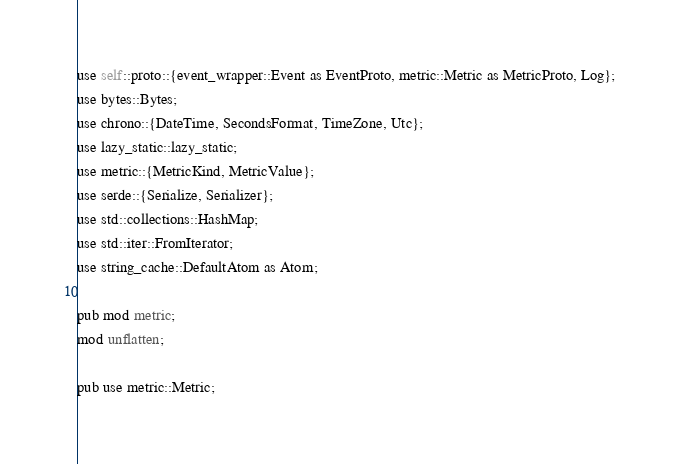<code> <loc_0><loc_0><loc_500><loc_500><_Rust_>use self::proto::{event_wrapper::Event as EventProto, metric::Metric as MetricProto, Log};
use bytes::Bytes;
use chrono::{DateTime, SecondsFormat, TimeZone, Utc};
use lazy_static::lazy_static;
use metric::{MetricKind, MetricValue};
use serde::{Serialize, Serializer};
use std::collections::HashMap;
use std::iter::FromIterator;
use string_cache::DefaultAtom as Atom;

pub mod metric;
mod unflatten;

pub use metric::Metric;
</code> 